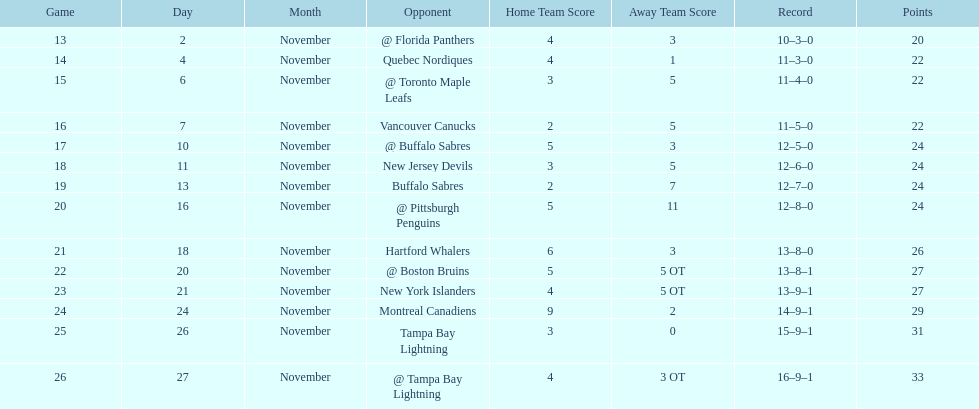Which was the only team in the atlantic division in the 1993-1994 season to acquire less points than the philadelphia flyers? Tampa Bay Lightning. 